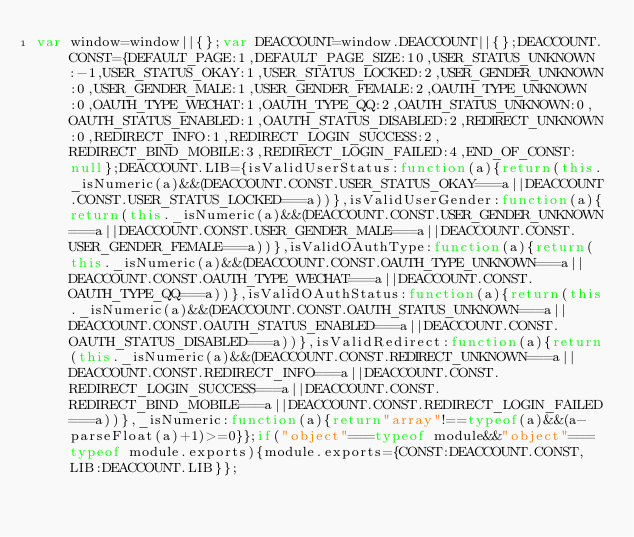<code> <loc_0><loc_0><loc_500><loc_500><_JavaScript_>var window=window||{};var DEACCOUNT=window.DEACCOUNT||{};DEACCOUNT.CONST={DEFAULT_PAGE:1,DEFAULT_PAGE_SIZE:10,USER_STATUS_UNKNOWN:-1,USER_STATUS_OKAY:1,USER_STATUS_LOCKED:2,USER_GENDER_UNKNOWN:0,USER_GENDER_MALE:1,USER_GENDER_FEMALE:2,OAUTH_TYPE_UNKNOWN:0,OAUTH_TYPE_WECHAT:1,OAUTH_TYPE_QQ:2,OAUTH_STATUS_UNKNOWN:0,OAUTH_STATUS_ENABLED:1,OAUTH_STATUS_DISABLED:2,REDIRECT_UNKNOWN:0,REDIRECT_INFO:1,REDIRECT_LOGIN_SUCCESS:2,REDIRECT_BIND_MOBILE:3,REDIRECT_LOGIN_FAILED:4,END_OF_CONST:null};DEACCOUNT.LIB={isValidUserStatus:function(a){return(this._isNumeric(a)&&(DEACCOUNT.CONST.USER_STATUS_OKAY===a||DEACCOUNT.CONST.USER_STATUS_LOCKED===a))},isValidUserGender:function(a){return(this._isNumeric(a)&&(DEACCOUNT.CONST.USER_GENDER_UNKNOWN===a||DEACCOUNT.CONST.USER_GENDER_MALE===a||DEACCOUNT.CONST.USER_GENDER_FEMALE===a))},isValidOAuthType:function(a){return(this._isNumeric(a)&&(DEACCOUNT.CONST.OAUTH_TYPE_UNKNOWN===a||DEACCOUNT.CONST.OAUTH_TYPE_WECHAT===a||DEACCOUNT.CONST.OAUTH_TYPE_QQ===a))},isValidOAuthStatus:function(a){return(this._isNumeric(a)&&(DEACCOUNT.CONST.OAUTH_STATUS_UNKNOWN===a||DEACCOUNT.CONST.OAUTH_STATUS_ENABLED===a||DEACCOUNT.CONST.OAUTH_STATUS_DISABLED===a))},isValidRedirect:function(a){return(this._isNumeric(a)&&(DEACCOUNT.CONST.REDIRECT_UNKNOWN===a||DEACCOUNT.CONST.REDIRECT_INFO===a||DEACCOUNT.CONST.REDIRECT_LOGIN_SUCCESS===a||DEACCOUNT.CONST.REDIRECT_BIND_MOBILE===a||DEACCOUNT.CONST.REDIRECT_LOGIN_FAILED===a))},_isNumeric:function(a){return"array"!==typeof(a)&&(a-parseFloat(a)+1)>=0}};if("object"===typeof module&&"object"===typeof module.exports){module.exports={CONST:DEACCOUNT.CONST,LIB:DEACCOUNT.LIB}};</code> 